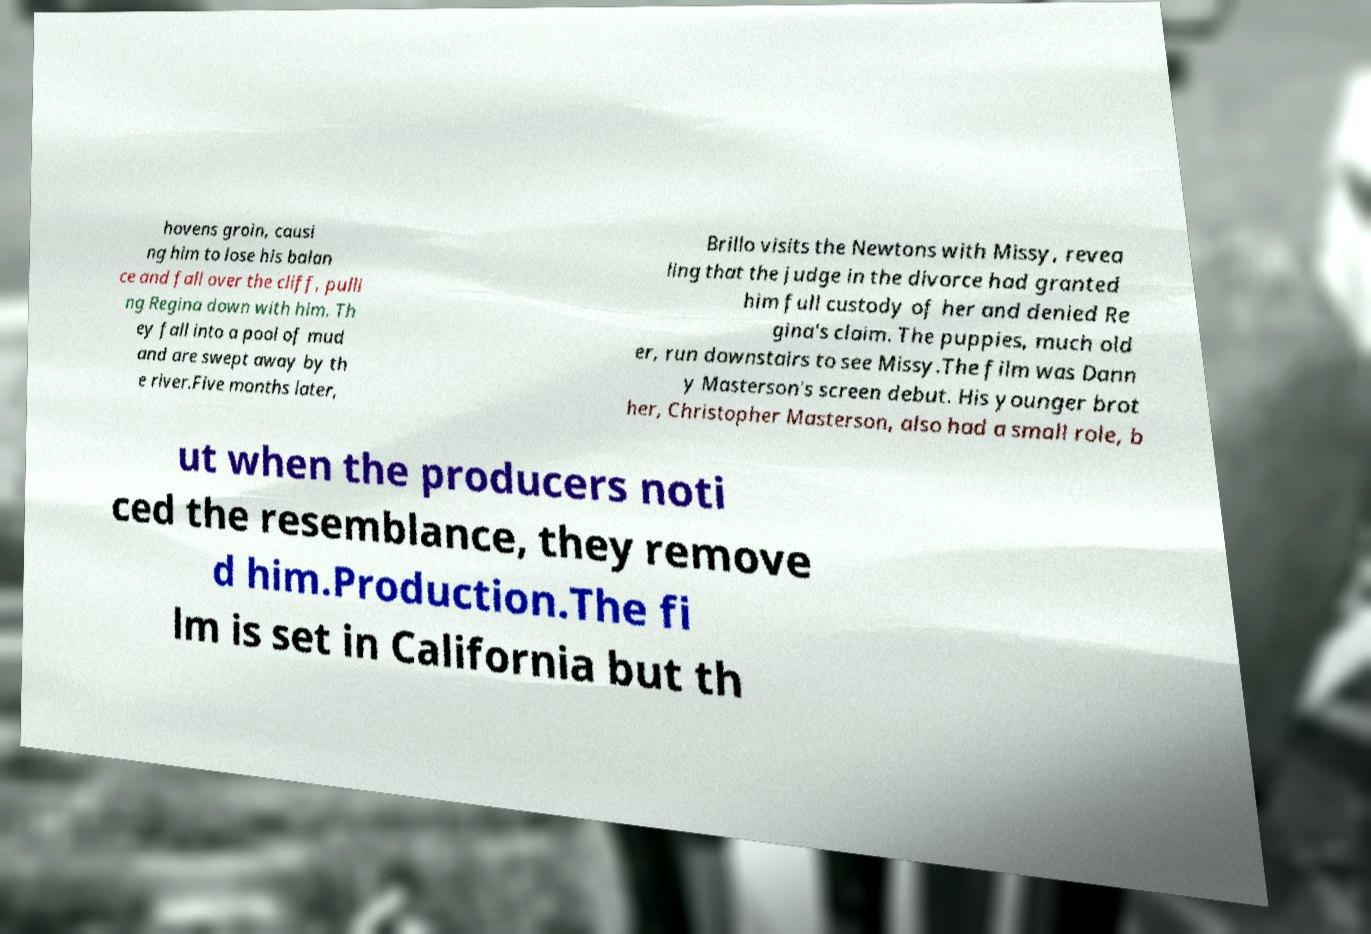I need the written content from this picture converted into text. Can you do that? hovens groin, causi ng him to lose his balan ce and fall over the cliff, pulli ng Regina down with him. Th ey fall into a pool of mud and are swept away by th e river.Five months later, Brillo visits the Newtons with Missy, revea ling that the judge in the divorce had granted him full custody of her and denied Re gina's claim. The puppies, much old er, run downstairs to see Missy.The film was Dann y Masterson's screen debut. His younger brot her, Christopher Masterson, also had a small role, b ut when the producers noti ced the resemblance, they remove d him.Production.The fi lm is set in California but th 